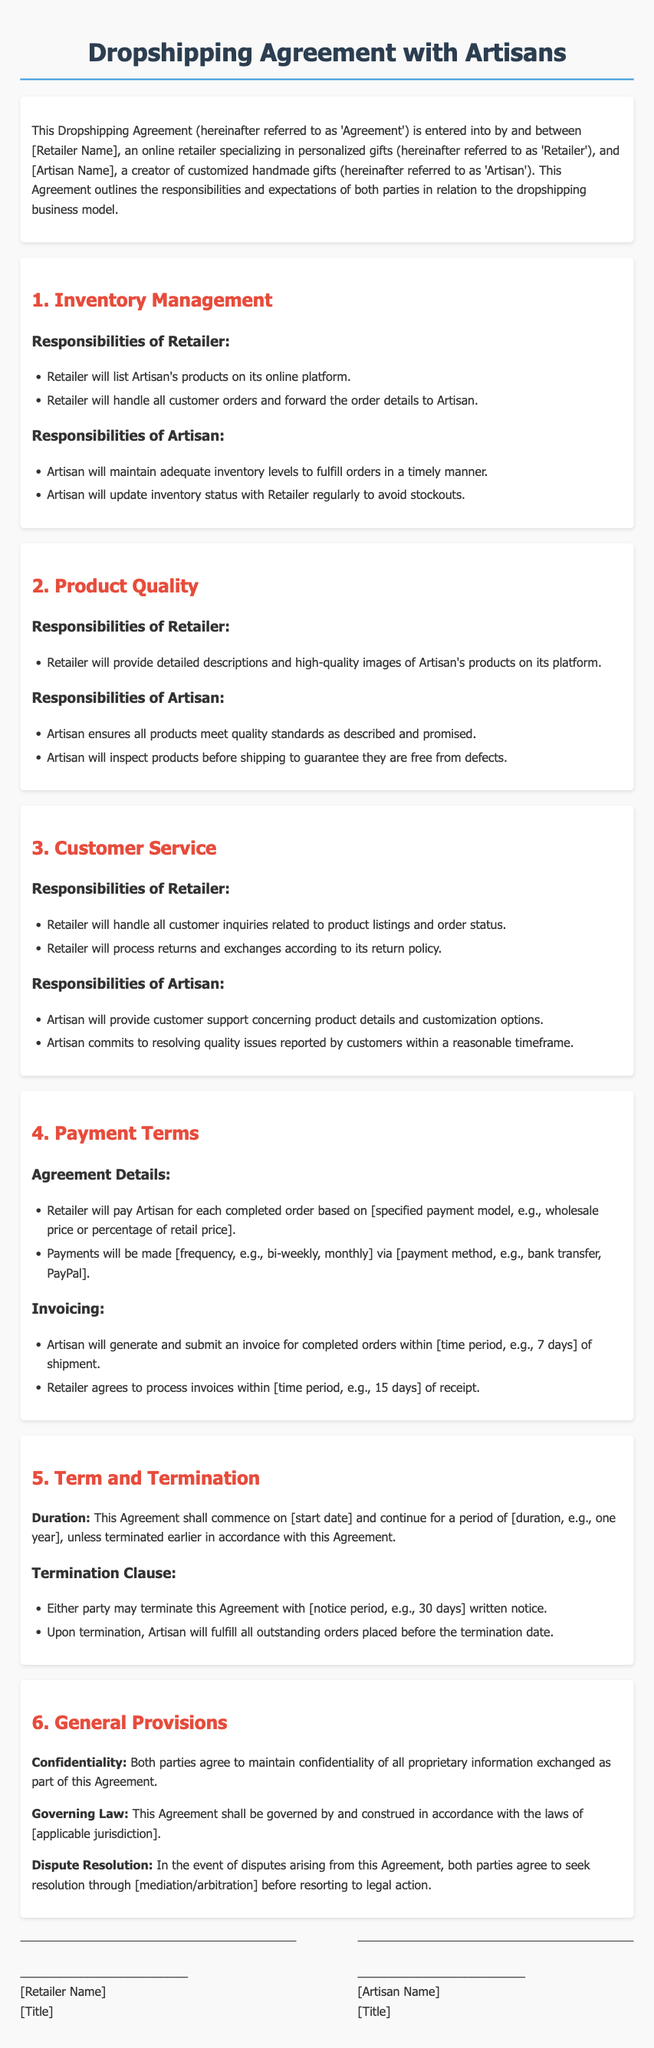what is the title of the document? The title of the document is prominently displayed at the top and indicates its purpose.
Answer: Dropshipping Agreement with Artisans who is responsible for updating inventory status? The document states specific responsibilities for both the retailer and the artisan for inventory management.
Answer: Artisan what are the payment terms specified for the retailer? The document outlines how payments will be structured and the frequency of payments made to the artisan.
Answer: Retailer will pay Artisan for each completed order based on specified payment model how long is the initial duration of the agreement? The document specifies a period for which the agreement will be active before it may be terminated or renewed.
Answer: one year what is required for either party to terminate the agreement? The document indicates the necessary action both parties must take to officially end the agreement.
Answer: written notice what does the general provision state regarding confidentiality? The general provisions section addresses key obligations both parties must follow throughout the agreement.
Answer: Both parties agree to maintain confidentiality how often will payments be processed? The document states how frequently payments will be made to the artisan after orders are fulfilled.
Answer: bi-weekly what type of dispute resolution is mentioned? The document specifies an approach for resolving conflicts that arise during the term of the agreement.
Answer: mediation/arbitration 